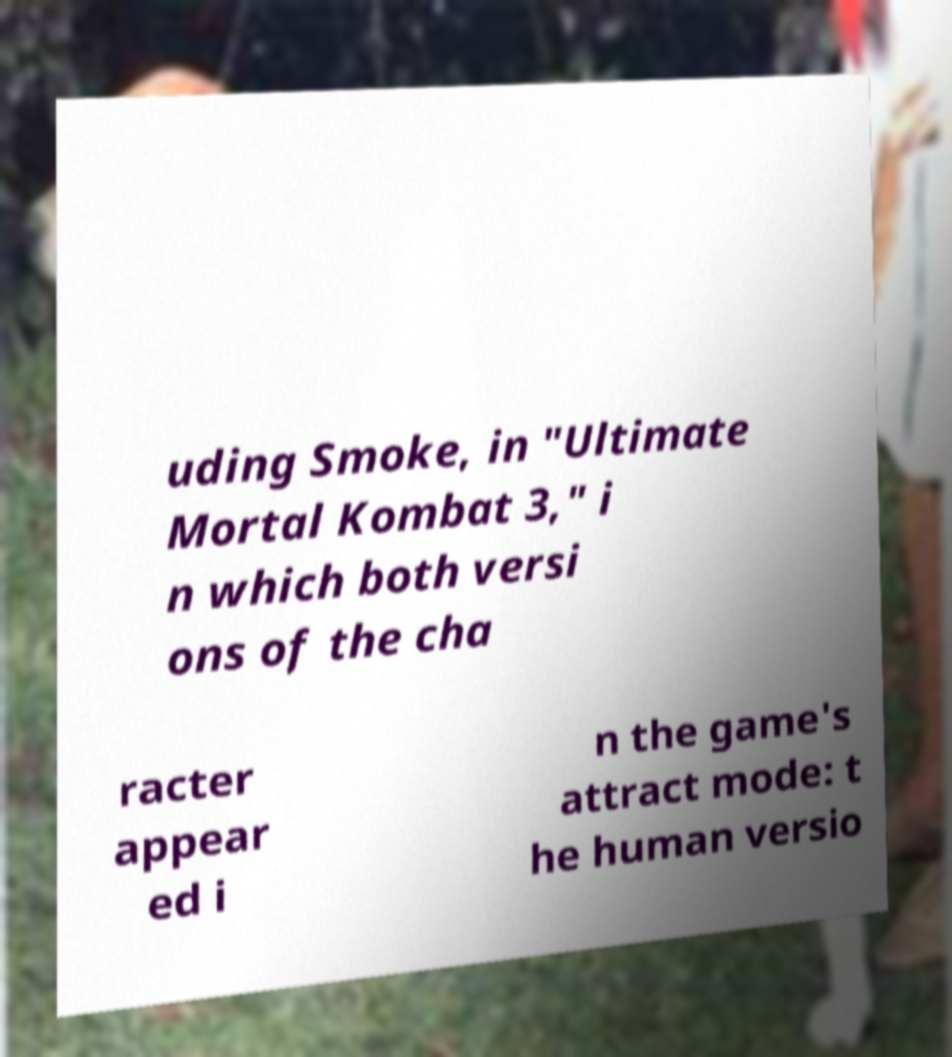Please identify and transcribe the text found in this image. uding Smoke, in "Ultimate Mortal Kombat 3," i n which both versi ons of the cha racter appear ed i n the game's attract mode: t he human versio 